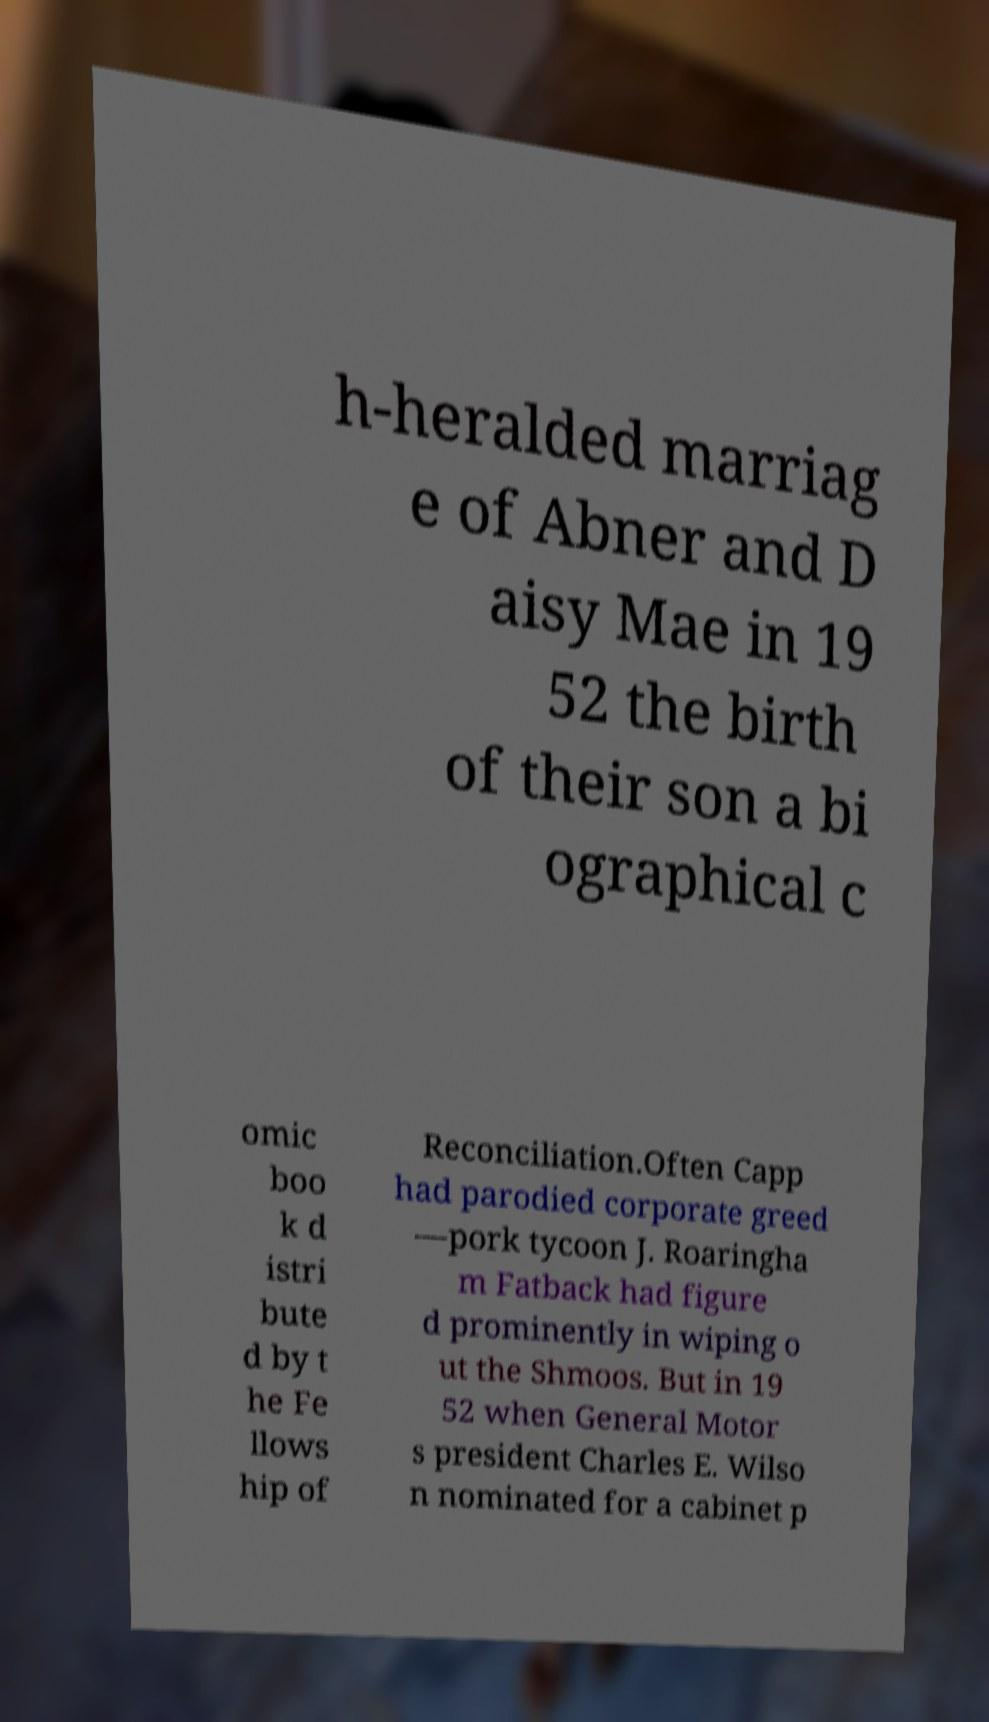Please read and relay the text visible in this image. What does it say? h-heralded marriag e of Abner and D aisy Mae in 19 52 the birth of their son a bi ographical c omic boo k d istri bute d by t he Fe llows hip of Reconciliation.Often Capp had parodied corporate greed —pork tycoon J. Roaringha m Fatback had figure d prominently in wiping o ut the Shmoos. But in 19 52 when General Motor s president Charles E. Wilso n nominated for a cabinet p 